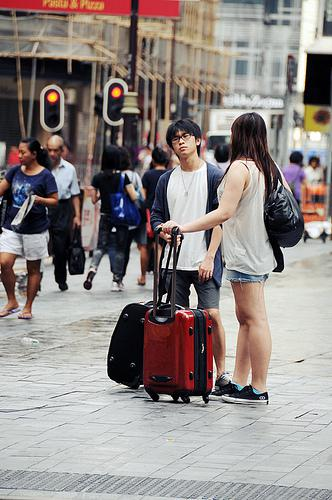Question: what color are the lights?
Choices:
A. Red.
B. Green.
C. Yellow.
D. White.
Answer with the letter. Answer: C Question: who is holding the handle of the red suitcase?
Choices:
A. A traveler.
B. The man's companion.
C. A flight attendant.
D. The woman.
Answer with the letter. Answer: D Question: where is the woman's purse?
Choices:
A. In her hand.
B. On her arm.
C. Over her shoulder.
D. Around her waist.
Answer with the letter. Answer: C Question: what color is the sidewalk?
Choices:
A. Gray.
B. Black.
C. Brown.
D. Tan.
Answer with the letter. Answer: A Question: what is in the background of the photo?
Choices:
A. Trees.
B. Mountains.
C. Buildings.
D. A fence.
Answer with the letter. Answer: C Question: who is wearing white shorts?
Choices:
A. The nurse.
B. The tall lady.
C. The man wearing a hat.
D. The black woman.
Answer with the letter. Answer: D 